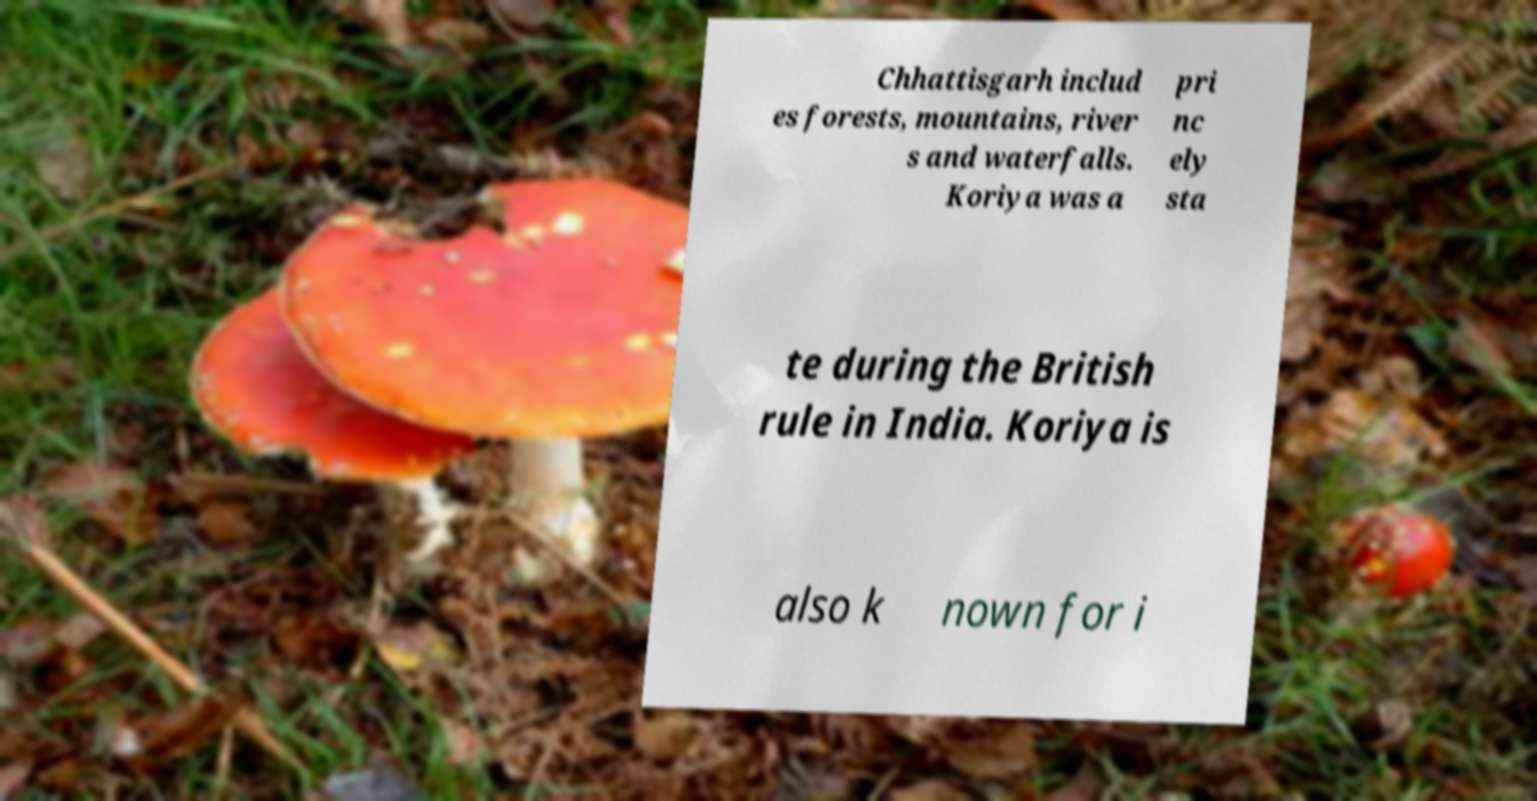For documentation purposes, I need the text within this image transcribed. Could you provide that? Chhattisgarh includ es forests, mountains, river s and waterfalls. Koriya was a pri nc ely sta te during the British rule in India. Koriya is also k nown for i 